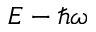Convert formula to latex. <formula><loc_0><loc_0><loc_500><loc_500>E - \hbar { \omega }</formula> 